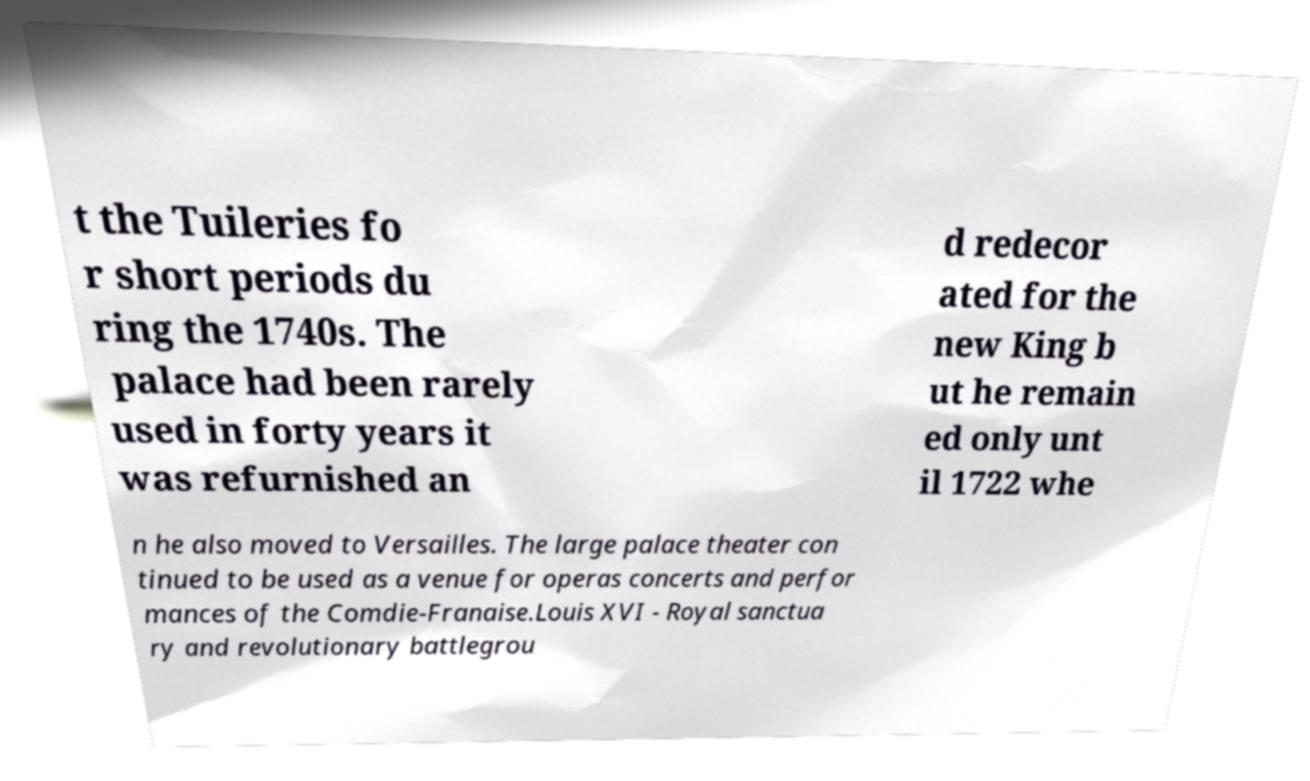What messages or text are displayed in this image? I need them in a readable, typed format. t the Tuileries fo r short periods du ring the 1740s. The palace had been rarely used in forty years it was refurnished an d redecor ated for the new King b ut he remain ed only unt il 1722 whe n he also moved to Versailles. The large palace theater con tinued to be used as a venue for operas concerts and perfor mances of the Comdie-Franaise.Louis XVI - Royal sanctua ry and revolutionary battlegrou 